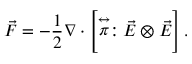<formula> <loc_0><loc_0><loc_500><loc_500>\vec { F } = - \frac { 1 } { 2 } \nabla \cdot \left [ \stackrel { \leftrightarrow } { \pi } \colon \vec { E } \otimes \vec { E } \right ] .</formula> 